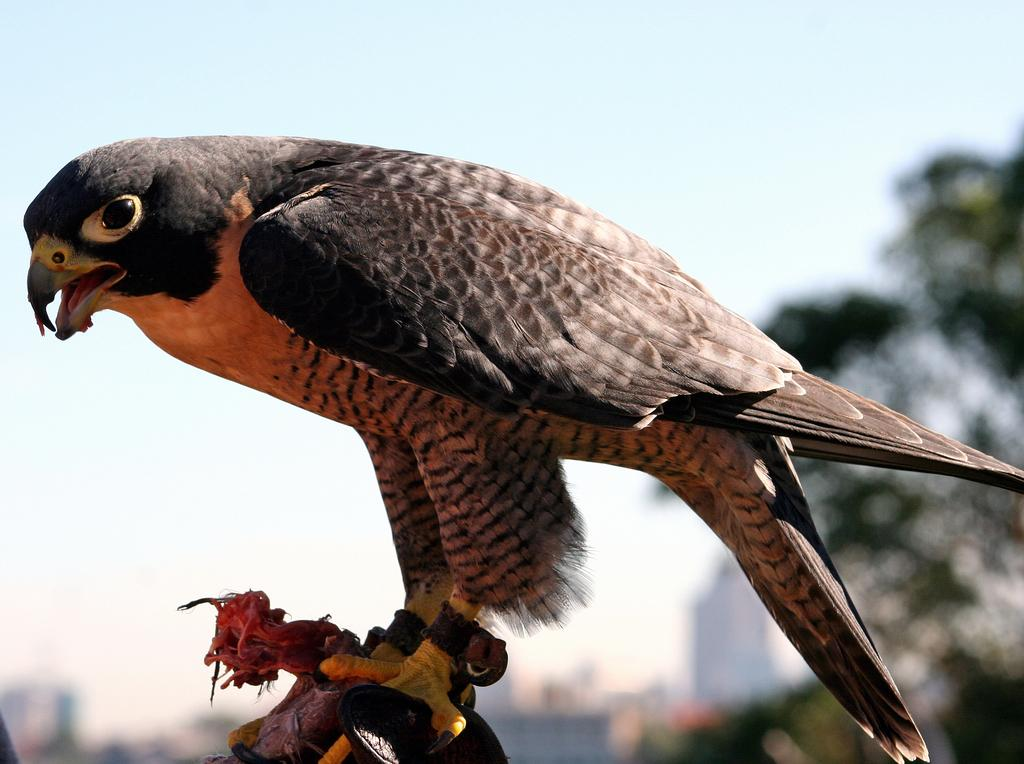What type of bird is in the image? There is an eagle bird in the image. What is the eagle bird doing in the image? The eagle bird is standing. Can you describe the background of the image? The background of the image is blurry. What type of curve can be seen on the stove in the image? There is no stove present in the image, and therefore no curve can be observed. 